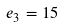<formula> <loc_0><loc_0><loc_500><loc_500>e _ { 3 } = 1 5</formula> 